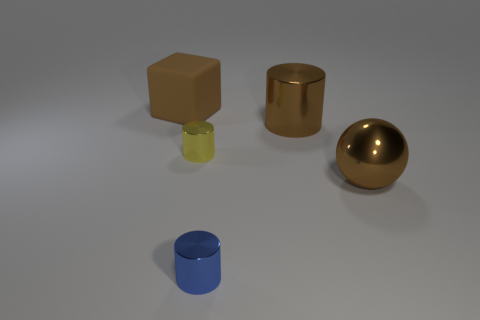Subtract all large cylinders. How many cylinders are left? 2 Add 2 big rubber objects. How many objects exist? 7 Subtract all cylinders. How many objects are left? 2 Subtract 0 blue blocks. How many objects are left? 5 Subtract all rubber things. Subtract all brown rubber cubes. How many objects are left? 3 Add 2 tiny blue metal cylinders. How many tiny blue metal cylinders are left? 3 Add 1 purple matte things. How many purple matte things exist? 1 